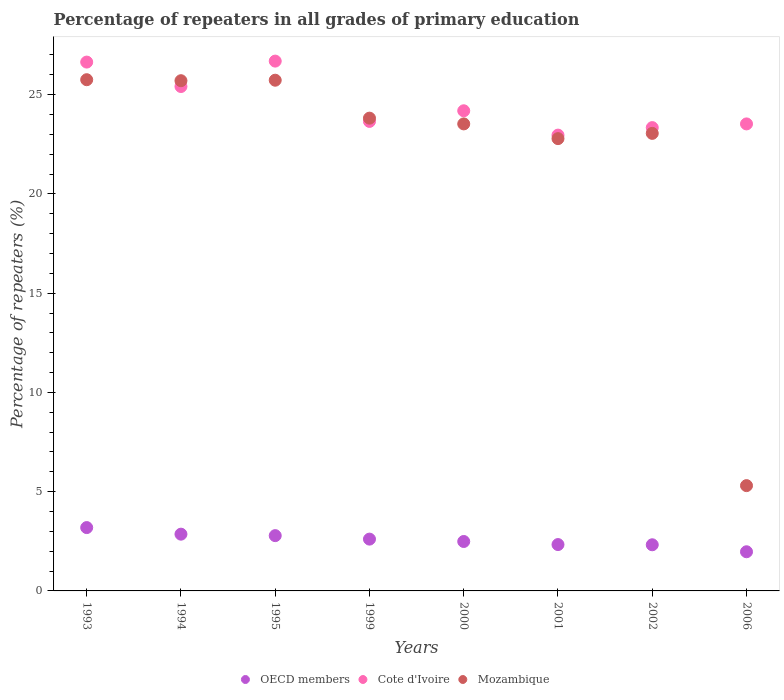How many different coloured dotlines are there?
Keep it short and to the point. 3. What is the percentage of repeaters in Cote d'Ivoire in 1995?
Your answer should be very brief. 26.69. Across all years, what is the maximum percentage of repeaters in OECD members?
Keep it short and to the point. 3.19. Across all years, what is the minimum percentage of repeaters in Mozambique?
Offer a very short reply. 5.3. In which year was the percentage of repeaters in OECD members minimum?
Your answer should be very brief. 2006. What is the total percentage of repeaters in Cote d'Ivoire in the graph?
Provide a short and direct response. 196.41. What is the difference between the percentage of repeaters in Cote d'Ivoire in 1995 and that in 2006?
Give a very brief answer. 3.16. What is the difference between the percentage of repeaters in Cote d'Ivoire in 2002 and the percentage of repeaters in Mozambique in 1995?
Provide a short and direct response. -2.39. What is the average percentage of repeaters in Mozambique per year?
Offer a very short reply. 21.96. In the year 1994, what is the difference between the percentage of repeaters in Mozambique and percentage of repeaters in OECD members?
Keep it short and to the point. 22.84. In how many years, is the percentage of repeaters in Cote d'Ivoire greater than 19 %?
Give a very brief answer. 8. What is the ratio of the percentage of repeaters in OECD members in 1995 to that in 2006?
Make the answer very short. 1.41. Is the difference between the percentage of repeaters in Mozambique in 1999 and 2000 greater than the difference between the percentage of repeaters in OECD members in 1999 and 2000?
Provide a short and direct response. Yes. What is the difference between the highest and the second highest percentage of repeaters in Cote d'Ivoire?
Offer a terse response. 0.05. What is the difference between the highest and the lowest percentage of repeaters in Mozambique?
Give a very brief answer. 20.45. Is the sum of the percentage of repeaters in Mozambique in 1993 and 2002 greater than the maximum percentage of repeaters in Cote d'Ivoire across all years?
Keep it short and to the point. Yes. Is it the case that in every year, the sum of the percentage of repeaters in Mozambique and percentage of repeaters in OECD members  is greater than the percentage of repeaters in Cote d'Ivoire?
Keep it short and to the point. No. Does the percentage of repeaters in Mozambique monotonically increase over the years?
Your response must be concise. No. How many dotlines are there?
Give a very brief answer. 3. How many years are there in the graph?
Your answer should be very brief. 8. Are the values on the major ticks of Y-axis written in scientific E-notation?
Give a very brief answer. No. How many legend labels are there?
Your answer should be compact. 3. How are the legend labels stacked?
Your answer should be compact. Horizontal. What is the title of the graph?
Offer a terse response. Percentage of repeaters in all grades of primary education. Does "Latin America(developing only)" appear as one of the legend labels in the graph?
Your answer should be very brief. No. What is the label or title of the X-axis?
Your answer should be compact. Years. What is the label or title of the Y-axis?
Your response must be concise. Percentage of repeaters (%). What is the Percentage of repeaters (%) in OECD members in 1993?
Provide a succinct answer. 3.19. What is the Percentage of repeaters (%) of Cote d'Ivoire in 1993?
Your answer should be very brief. 26.64. What is the Percentage of repeaters (%) in Mozambique in 1993?
Ensure brevity in your answer.  25.75. What is the Percentage of repeaters (%) in OECD members in 1994?
Keep it short and to the point. 2.86. What is the Percentage of repeaters (%) of Cote d'Ivoire in 1994?
Offer a very short reply. 25.41. What is the Percentage of repeaters (%) of Mozambique in 1994?
Ensure brevity in your answer.  25.7. What is the Percentage of repeaters (%) of OECD members in 1995?
Your answer should be compact. 2.79. What is the Percentage of repeaters (%) in Cote d'Ivoire in 1995?
Give a very brief answer. 26.69. What is the Percentage of repeaters (%) of Mozambique in 1995?
Your answer should be very brief. 25.73. What is the Percentage of repeaters (%) in OECD members in 1999?
Provide a short and direct response. 2.61. What is the Percentage of repeaters (%) of Cote d'Ivoire in 1999?
Your response must be concise. 23.65. What is the Percentage of repeaters (%) in Mozambique in 1999?
Give a very brief answer. 23.82. What is the Percentage of repeaters (%) of OECD members in 2000?
Provide a succinct answer. 2.49. What is the Percentage of repeaters (%) of Cote d'Ivoire in 2000?
Keep it short and to the point. 24.19. What is the Percentage of repeaters (%) of Mozambique in 2000?
Make the answer very short. 23.53. What is the Percentage of repeaters (%) of OECD members in 2001?
Offer a very short reply. 2.34. What is the Percentage of repeaters (%) of Cote d'Ivoire in 2001?
Offer a terse response. 22.96. What is the Percentage of repeaters (%) in Mozambique in 2001?
Your answer should be very brief. 22.78. What is the Percentage of repeaters (%) in OECD members in 2002?
Provide a short and direct response. 2.32. What is the Percentage of repeaters (%) in Cote d'Ivoire in 2002?
Offer a terse response. 23.34. What is the Percentage of repeaters (%) in Mozambique in 2002?
Your answer should be compact. 23.05. What is the Percentage of repeaters (%) of OECD members in 2006?
Ensure brevity in your answer.  1.97. What is the Percentage of repeaters (%) in Cote d'Ivoire in 2006?
Your response must be concise. 23.53. What is the Percentage of repeaters (%) in Mozambique in 2006?
Your response must be concise. 5.3. Across all years, what is the maximum Percentage of repeaters (%) in OECD members?
Your answer should be very brief. 3.19. Across all years, what is the maximum Percentage of repeaters (%) in Cote d'Ivoire?
Your answer should be compact. 26.69. Across all years, what is the maximum Percentage of repeaters (%) of Mozambique?
Your answer should be compact. 25.75. Across all years, what is the minimum Percentage of repeaters (%) in OECD members?
Keep it short and to the point. 1.97. Across all years, what is the minimum Percentage of repeaters (%) of Cote d'Ivoire?
Make the answer very short. 22.96. Across all years, what is the minimum Percentage of repeaters (%) in Mozambique?
Your answer should be very brief. 5.3. What is the total Percentage of repeaters (%) of OECD members in the graph?
Your response must be concise. 20.57. What is the total Percentage of repeaters (%) in Cote d'Ivoire in the graph?
Give a very brief answer. 196.41. What is the total Percentage of repeaters (%) in Mozambique in the graph?
Keep it short and to the point. 175.67. What is the difference between the Percentage of repeaters (%) of OECD members in 1993 and that in 1994?
Ensure brevity in your answer.  0.33. What is the difference between the Percentage of repeaters (%) in Cote d'Ivoire in 1993 and that in 1994?
Offer a very short reply. 1.23. What is the difference between the Percentage of repeaters (%) in Mozambique in 1993 and that in 1994?
Make the answer very short. 0.05. What is the difference between the Percentage of repeaters (%) of OECD members in 1993 and that in 1995?
Offer a terse response. 0.41. What is the difference between the Percentage of repeaters (%) of Cote d'Ivoire in 1993 and that in 1995?
Your answer should be compact. -0.05. What is the difference between the Percentage of repeaters (%) in Mozambique in 1993 and that in 1995?
Give a very brief answer. 0.03. What is the difference between the Percentage of repeaters (%) in OECD members in 1993 and that in 1999?
Your response must be concise. 0.58. What is the difference between the Percentage of repeaters (%) of Cote d'Ivoire in 1993 and that in 1999?
Provide a short and direct response. 2.99. What is the difference between the Percentage of repeaters (%) in Mozambique in 1993 and that in 1999?
Your answer should be compact. 1.94. What is the difference between the Percentage of repeaters (%) in OECD members in 1993 and that in 2000?
Your answer should be compact. 0.7. What is the difference between the Percentage of repeaters (%) in Cote d'Ivoire in 1993 and that in 2000?
Keep it short and to the point. 2.45. What is the difference between the Percentage of repeaters (%) of Mozambique in 1993 and that in 2000?
Provide a succinct answer. 2.23. What is the difference between the Percentage of repeaters (%) of OECD members in 1993 and that in 2001?
Provide a short and direct response. 0.86. What is the difference between the Percentage of repeaters (%) of Cote d'Ivoire in 1993 and that in 2001?
Your response must be concise. 3.68. What is the difference between the Percentage of repeaters (%) in Mozambique in 1993 and that in 2001?
Provide a succinct answer. 2.97. What is the difference between the Percentage of repeaters (%) in OECD members in 1993 and that in 2002?
Your answer should be compact. 0.87. What is the difference between the Percentage of repeaters (%) of Cote d'Ivoire in 1993 and that in 2002?
Give a very brief answer. 3.3. What is the difference between the Percentage of repeaters (%) of Mozambique in 1993 and that in 2002?
Make the answer very short. 2.7. What is the difference between the Percentage of repeaters (%) of OECD members in 1993 and that in 2006?
Your answer should be compact. 1.22. What is the difference between the Percentage of repeaters (%) in Cote d'Ivoire in 1993 and that in 2006?
Offer a very short reply. 3.11. What is the difference between the Percentage of repeaters (%) of Mozambique in 1993 and that in 2006?
Offer a very short reply. 20.45. What is the difference between the Percentage of repeaters (%) in OECD members in 1994 and that in 1995?
Provide a short and direct response. 0.07. What is the difference between the Percentage of repeaters (%) in Cote d'Ivoire in 1994 and that in 1995?
Your response must be concise. -1.28. What is the difference between the Percentage of repeaters (%) in Mozambique in 1994 and that in 1995?
Give a very brief answer. -0.02. What is the difference between the Percentage of repeaters (%) of OECD members in 1994 and that in 1999?
Your answer should be compact. 0.25. What is the difference between the Percentage of repeaters (%) of Cote d'Ivoire in 1994 and that in 1999?
Keep it short and to the point. 1.76. What is the difference between the Percentage of repeaters (%) in Mozambique in 1994 and that in 1999?
Offer a terse response. 1.89. What is the difference between the Percentage of repeaters (%) of OECD members in 1994 and that in 2000?
Give a very brief answer. 0.37. What is the difference between the Percentage of repeaters (%) of Cote d'Ivoire in 1994 and that in 2000?
Offer a very short reply. 1.22. What is the difference between the Percentage of repeaters (%) of Mozambique in 1994 and that in 2000?
Offer a very short reply. 2.18. What is the difference between the Percentage of repeaters (%) in OECD members in 1994 and that in 2001?
Offer a very short reply. 0.52. What is the difference between the Percentage of repeaters (%) in Cote d'Ivoire in 1994 and that in 2001?
Your response must be concise. 2.45. What is the difference between the Percentage of repeaters (%) of Mozambique in 1994 and that in 2001?
Your answer should be very brief. 2.92. What is the difference between the Percentage of repeaters (%) of OECD members in 1994 and that in 2002?
Offer a terse response. 0.53. What is the difference between the Percentage of repeaters (%) in Cote d'Ivoire in 1994 and that in 2002?
Keep it short and to the point. 2.07. What is the difference between the Percentage of repeaters (%) in Mozambique in 1994 and that in 2002?
Keep it short and to the point. 2.65. What is the difference between the Percentage of repeaters (%) of OECD members in 1994 and that in 2006?
Your answer should be very brief. 0.89. What is the difference between the Percentage of repeaters (%) in Cote d'Ivoire in 1994 and that in 2006?
Make the answer very short. 1.88. What is the difference between the Percentage of repeaters (%) of Mozambique in 1994 and that in 2006?
Ensure brevity in your answer.  20.4. What is the difference between the Percentage of repeaters (%) of OECD members in 1995 and that in 1999?
Your answer should be compact. 0.18. What is the difference between the Percentage of repeaters (%) of Cote d'Ivoire in 1995 and that in 1999?
Your response must be concise. 3.04. What is the difference between the Percentage of repeaters (%) in Mozambique in 1995 and that in 1999?
Offer a terse response. 1.91. What is the difference between the Percentage of repeaters (%) in OECD members in 1995 and that in 2000?
Offer a terse response. 0.29. What is the difference between the Percentage of repeaters (%) in Cote d'Ivoire in 1995 and that in 2000?
Provide a short and direct response. 2.5. What is the difference between the Percentage of repeaters (%) in Mozambique in 1995 and that in 2000?
Your answer should be very brief. 2.2. What is the difference between the Percentage of repeaters (%) of OECD members in 1995 and that in 2001?
Make the answer very short. 0.45. What is the difference between the Percentage of repeaters (%) of Cote d'Ivoire in 1995 and that in 2001?
Give a very brief answer. 3.73. What is the difference between the Percentage of repeaters (%) in Mozambique in 1995 and that in 2001?
Offer a very short reply. 2.94. What is the difference between the Percentage of repeaters (%) in OECD members in 1995 and that in 2002?
Keep it short and to the point. 0.46. What is the difference between the Percentage of repeaters (%) of Cote d'Ivoire in 1995 and that in 2002?
Give a very brief answer. 3.35. What is the difference between the Percentage of repeaters (%) in Mozambique in 1995 and that in 2002?
Ensure brevity in your answer.  2.68. What is the difference between the Percentage of repeaters (%) of OECD members in 1995 and that in 2006?
Offer a very short reply. 0.81. What is the difference between the Percentage of repeaters (%) of Cote d'Ivoire in 1995 and that in 2006?
Your answer should be compact. 3.16. What is the difference between the Percentage of repeaters (%) in Mozambique in 1995 and that in 2006?
Provide a short and direct response. 20.42. What is the difference between the Percentage of repeaters (%) in OECD members in 1999 and that in 2000?
Provide a short and direct response. 0.12. What is the difference between the Percentage of repeaters (%) in Cote d'Ivoire in 1999 and that in 2000?
Offer a very short reply. -0.54. What is the difference between the Percentage of repeaters (%) of Mozambique in 1999 and that in 2000?
Your response must be concise. 0.29. What is the difference between the Percentage of repeaters (%) in OECD members in 1999 and that in 2001?
Your answer should be compact. 0.27. What is the difference between the Percentage of repeaters (%) of Cote d'Ivoire in 1999 and that in 2001?
Your answer should be compact. 0.69. What is the difference between the Percentage of repeaters (%) in Mozambique in 1999 and that in 2001?
Provide a short and direct response. 1.03. What is the difference between the Percentage of repeaters (%) in OECD members in 1999 and that in 2002?
Offer a terse response. 0.29. What is the difference between the Percentage of repeaters (%) of Cote d'Ivoire in 1999 and that in 2002?
Ensure brevity in your answer.  0.31. What is the difference between the Percentage of repeaters (%) of Mozambique in 1999 and that in 2002?
Your answer should be compact. 0.77. What is the difference between the Percentage of repeaters (%) in OECD members in 1999 and that in 2006?
Keep it short and to the point. 0.64. What is the difference between the Percentage of repeaters (%) in Cote d'Ivoire in 1999 and that in 2006?
Your response must be concise. 0.13. What is the difference between the Percentage of repeaters (%) in Mozambique in 1999 and that in 2006?
Your response must be concise. 18.51. What is the difference between the Percentage of repeaters (%) in OECD members in 2000 and that in 2001?
Provide a succinct answer. 0.15. What is the difference between the Percentage of repeaters (%) of Cote d'Ivoire in 2000 and that in 2001?
Your response must be concise. 1.23. What is the difference between the Percentage of repeaters (%) in Mozambique in 2000 and that in 2001?
Your response must be concise. 0.74. What is the difference between the Percentage of repeaters (%) of OECD members in 2000 and that in 2002?
Your response must be concise. 0.17. What is the difference between the Percentage of repeaters (%) in Cote d'Ivoire in 2000 and that in 2002?
Provide a short and direct response. 0.85. What is the difference between the Percentage of repeaters (%) of Mozambique in 2000 and that in 2002?
Provide a short and direct response. 0.48. What is the difference between the Percentage of repeaters (%) in OECD members in 2000 and that in 2006?
Offer a very short reply. 0.52. What is the difference between the Percentage of repeaters (%) of Cote d'Ivoire in 2000 and that in 2006?
Offer a terse response. 0.66. What is the difference between the Percentage of repeaters (%) in Mozambique in 2000 and that in 2006?
Make the answer very short. 18.22. What is the difference between the Percentage of repeaters (%) of OECD members in 2001 and that in 2002?
Your response must be concise. 0.01. What is the difference between the Percentage of repeaters (%) in Cote d'Ivoire in 2001 and that in 2002?
Keep it short and to the point. -0.38. What is the difference between the Percentage of repeaters (%) in Mozambique in 2001 and that in 2002?
Your answer should be very brief. -0.26. What is the difference between the Percentage of repeaters (%) in OECD members in 2001 and that in 2006?
Keep it short and to the point. 0.36. What is the difference between the Percentage of repeaters (%) of Cote d'Ivoire in 2001 and that in 2006?
Your answer should be compact. -0.56. What is the difference between the Percentage of repeaters (%) of Mozambique in 2001 and that in 2006?
Offer a terse response. 17.48. What is the difference between the Percentage of repeaters (%) of OECD members in 2002 and that in 2006?
Ensure brevity in your answer.  0.35. What is the difference between the Percentage of repeaters (%) in Cote d'Ivoire in 2002 and that in 2006?
Offer a very short reply. -0.19. What is the difference between the Percentage of repeaters (%) in Mozambique in 2002 and that in 2006?
Ensure brevity in your answer.  17.75. What is the difference between the Percentage of repeaters (%) in OECD members in 1993 and the Percentage of repeaters (%) in Cote d'Ivoire in 1994?
Make the answer very short. -22.22. What is the difference between the Percentage of repeaters (%) in OECD members in 1993 and the Percentage of repeaters (%) in Mozambique in 1994?
Offer a very short reply. -22.51. What is the difference between the Percentage of repeaters (%) of Cote d'Ivoire in 1993 and the Percentage of repeaters (%) of Mozambique in 1994?
Your answer should be very brief. 0.94. What is the difference between the Percentage of repeaters (%) in OECD members in 1993 and the Percentage of repeaters (%) in Cote d'Ivoire in 1995?
Your answer should be very brief. -23.5. What is the difference between the Percentage of repeaters (%) in OECD members in 1993 and the Percentage of repeaters (%) in Mozambique in 1995?
Your answer should be very brief. -22.54. What is the difference between the Percentage of repeaters (%) of Cote d'Ivoire in 1993 and the Percentage of repeaters (%) of Mozambique in 1995?
Offer a very short reply. 0.91. What is the difference between the Percentage of repeaters (%) in OECD members in 1993 and the Percentage of repeaters (%) in Cote d'Ivoire in 1999?
Give a very brief answer. -20.46. What is the difference between the Percentage of repeaters (%) of OECD members in 1993 and the Percentage of repeaters (%) of Mozambique in 1999?
Offer a terse response. -20.63. What is the difference between the Percentage of repeaters (%) of Cote d'Ivoire in 1993 and the Percentage of repeaters (%) of Mozambique in 1999?
Ensure brevity in your answer.  2.82. What is the difference between the Percentage of repeaters (%) in OECD members in 1993 and the Percentage of repeaters (%) in Cote d'Ivoire in 2000?
Keep it short and to the point. -21. What is the difference between the Percentage of repeaters (%) in OECD members in 1993 and the Percentage of repeaters (%) in Mozambique in 2000?
Make the answer very short. -20.34. What is the difference between the Percentage of repeaters (%) of Cote d'Ivoire in 1993 and the Percentage of repeaters (%) of Mozambique in 2000?
Provide a short and direct response. 3.11. What is the difference between the Percentage of repeaters (%) in OECD members in 1993 and the Percentage of repeaters (%) in Cote d'Ivoire in 2001?
Provide a short and direct response. -19.77. What is the difference between the Percentage of repeaters (%) of OECD members in 1993 and the Percentage of repeaters (%) of Mozambique in 2001?
Keep it short and to the point. -19.59. What is the difference between the Percentage of repeaters (%) of Cote d'Ivoire in 1993 and the Percentage of repeaters (%) of Mozambique in 2001?
Keep it short and to the point. 3.86. What is the difference between the Percentage of repeaters (%) of OECD members in 1993 and the Percentage of repeaters (%) of Cote d'Ivoire in 2002?
Your answer should be compact. -20.15. What is the difference between the Percentage of repeaters (%) of OECD members in 1993 and the Percentage of repeaters (%) of Mozambique in 2002?
Provide a short and direct response. -19.86. What is the difference between the Percentage of repeaters (%) of Cote d'Ivoire in 1993 and the Percentage of repeaters (%) of Mozambique in 2002?
Your response must be concise. 3.59. What is the difference between the Percentage of repeaters (%) of OECD members in 1993 and the Percentage of repeaters (%) of Cote d'Ivoire in 2006?
Make the answer very short. -20.34. What is the difference between the Percentage of repeaters (%) of OECD members in 1993 and the Percentage of repeaters (%) of Mozambique in 2006?
Give a very brief answer. -2.11. What is the difference between the Percentage of repeaters (%) of Cote d'Ivoire in 1993 and the Percentage of repeaters (%) of Mozambique in 2006?
Ensure brevity in your answer.  21.34. What is the difference between the Percentage of repeaters (%) in OECD members in 1994 and the Percentage of repeaters (%) in Cote d'Ivoire in 1995?
Provide a short and direct response. -23.83. What is the difference between the Percentage of repeaters (%) in OECD members in 1994 and the Percentage of repeaters (%) in Mozambique in 1995?
Offer a terse response. -22.87. What is the difference between the Percentage of repeaters (%) in Cote d'Ivoire in 1994 and the Percentage of repeaters (%) in Mozambique in 1995?
Make the answer very short. -0.32. What is the difference between the Percentage of repeaters (%) in OECD members in 1994 and the Percentage of repeaters (%) in Cote d'Ivoire in 1999?
Your answer should be compact. -20.79. What is the difference between the Percentage of repeaters (%) in OECD members in 1994 and the Percentage of repeaters (%) in Mozambique in 1999?
Your response must be concise. -20.96. What is the difference between the Percentage of repeaters (%) of Cote d'Ivoire in 1994 and the Percentage of repeaters (%) of Mozambique in 1999?
Your answer should be compact. 1.59. What is the difference between the Percentage of repeaters (%) in OECD members in 1994 and the Percentage of repeaters (%) in Cote d'Ivoire in 2000?
Give a very brief answer. -21.33. What is the difference between the Percentage of repeaters (%) of OECD members in 1994 and the Percentage of repeaters (%) of Mozambique in 2000?
Provide a short and direct response. -20.67. What is the difference between the Percentage of repeaters (%) in Cote d'Ivoire in 1994 and the Percentage of repeaters (%) in Mozambique in 2000?
Give a very brief answer. 1.88. What is the difference between the Percentage of repeaters (%) in OECD members in 1994 and the Percentage of repeaters (%) in Cote d'Ivoire in 2001?
Provide a succinct answer. -20.1. What is the difference between the Percentage of repeaters (%) of OECD members in 1994 and the Percentage of repeaters (%) of Mozambique in 2001?
Provide a short and direct response. -19.93. What is the difference between the Percentage of repeaters (%) of Cote d'Ivoire in 1994 and the Percentage of repeaters (%) of Mozambique in 2001?
Ensure brevity in your answer.  2.63. What is the difference between the Percentage of repeaters (%) in OECD members in 1994 and the Percentage of repeaters (%) in Cote d'Ivoire in 2002?
Ensure brevity in your answer.  -20.48. What is the difference between the Percentage of repeaters (%) of OECD members in 1994 and the Percentage of repeaters (%) of Mozambique in 2002?
Provide a succinct answer. -20.19. What is the difference between the Percentage of repeaters (%) in Cote d'Ivoire in 1994 and the Percentage of repeaters (%) in Mozambique in 2002?
Keep it short and to the point. 2.36. What is the difference between the Percentage of repeaters (%) in OECD members in 1994 and the Percentage of repeaters (%) in Cote d'Ivoire in 2006?
Give a very brief answer. -20.67. What is the difference between the Percentage of repeaters (%) in OECD members in 1994 and the Percentage of repeaters (%) in Mozambique in 2006?
Your answer should be compact. -2.45. What is the difference between the Percentage of repeaters (%) in Cote d'Ivoire in 1994 and the Percentage of repeaters (%) in Mozambique in 2006?
Offer a very short reply. 20.11. What is the difference between the Percentage of repeaters (%) of OECD members in 1995 and the Percentage of repeaters (%) of Cote d'Ivoire in 1999?
Give a very brief answer. -20.87. What is the difference between the Percentage of repeaters (%) of OECD members in 1995 and the Percentage of repeaters (%) of Mozambique in 1999?
Make the answer very short. -21.03. What is the difference between the Percentage of repeaters (%) in Cote d'Ivoire in 1995 and the Percentage of repeaters (%) in Mozambique in 1999?
Your answer should be very brief. 2.87. What is the difference between the Percentage of repeaters (%) in OECD members in 1995 and the Percentage of repeaters (%) in Cote d'Ivoire in 2000?
Offer a very short reply. -21.4. What is the difference between the Percentage of repeaters (%) of OECD members in 1995 and the Percentage of repeaters (%) of Mozambique in 2000?
Keep it short and to the point. -20.74. What is the difference between the Percentage of repeaters (%) in Cote d'Ivoire in 1995 and the Percentage of repeaters (%) in Mozambique in 2000?
Offer a terse response. 3.16. What is the difference between the Percentage of repeaters (%) in OECD members in 1995 and the Percentage of repeaters (%) in Cote d'Ivoire in 2001?
Keep it short and to the point. -20.18. What is the difference between the Percentage of repeaters (%) of OECD members in 1995 and the Percentage of repeaters (%) of Mozambique in 2001?
Your answer should be very brief. -20. What is the difference between the Percentage of repeaters (%) of Cote d'Ivoire in 1995 and the Percentage of repeaters (%) of Mozambique in 2001?
Your answer should be compact. 3.91. What is the difference between the Percentage of repeaters (%) in OECD members in 1995 and the Percentage of repeaters (%) in Cote d'Ivoire in 2002?
Provide a succinct answer. -20.55. What is the difference between the Percentage of repeaters (%) in OECD members in 1995 and the Percentage of repeaters (%) in Mozambique in 2002?
Offer a terse response. -20.26. What is the difference between the Percentage of repeaters (%) in Cote d'Ivoire in 1995 and the Percentage of repeaters (%) in Mozambique in 2002?
Offer a terse response. 3.64. What is the difference between the Percentage of repeaters (%) in OECD members in 1995 and the Percentage of repeaters (%) in Cote d'Ivoire in 2006?
Ensure brevity in your answer.  -20.74. What is the difference between the Percentage of repeaters (%) in OECD members in 1995 and the Percentage of repeaters (%) in Mozambique in 2006?
Offer a very short reply. -2.52. What is the difference between the Percentage of repeaters (%) in Cote d'Ivoire in 1995 and the Percentage of repeaters (%) in Mozambique in 2006?
Make the answer very short. 21.39. What is the difference between the Percentage of repeaters (%) in OECD members in 1999 and the Percentage of repeaters (%) in Cote d'Ivoire in 2000?
Give a very brief answer. -21.58. What is the difference between the Percentage of repeaters (%) in OECD members in 1999 and the Percentage of repeaters (%) in Mozambique in 2000?
Make the answer very short. -20.92. What is the difference between the Percentage of repeaters (%) in Cote d'Ivoire in 1999 and the Percentage of repeaters (%) in Mozambique in 2000?
Offer a very short reply. 0.13. What is the difference between the Percentage of repeaters (%) in OECD members in 1999 and the Percentage of repeaters (%) in Cote d'Ivoire in 2001?
Offer a terse response. -20.35. What is the difference between the Percentage of repeaters (%) in OECD members in 1999 and the Percentage of repeaters (%) in Mozambique in 2001?
Your answer should be very brief. -20.18. What is the difference between the Percentage of repeaters (%) in Cote d'Ivoire in 1999 and the Percentage of repeaters (%) in Mozambique in 2001?
Your response must be concise. 0.87. What is the difference between the Percentage of repeaters (%) of OECD members in 1999 and the Percentage of repeaters (%) of Cote d'Ivoire in 2002?
Your response must be concise. -20.73. What is the difference between the Percentage of repeaters (%) of OECD members in 1999 and the Percentage of repeaters (%) of Mozambique in 2002?
Provide a short and direct response. -20.44. What is the difference between the Percentage of repeaters (%) in Cote d'Ivoire in 1999 and the Percentage of repeaters (%) in Mozambique in 2002?
Provide a short and direct response. 0.6. What is the difference between the Percentage of repeaters (%) of OECD members in 1999 and the Percentage of repeaters (%) of Cote d'Ivoire in 2006?
Keep it short and to the point. -20.92. What is the difference between the Percentage of repeaters (%) of OECD members in 1999 and the Percentage of repeaters (%) of Mozambique in 2006?
Your answer should be very brief. -2.69. What is the difference between the Percentage of repeaters (%) of Cote d'Ivoire in 1999 and the Percentage of repeaters (%) of Mozambique in 2006?
Keep it short and to the point. 18.35. What is the difference between the Percentage of repeaters (%) in OECD members in 2000 and the Percentage of repeaters (%) in Cote d'Ivoire in 2001?
Offer a terse response. -20.47. What is the difference between the Percentage of repeaters (%) in OECD members in 2000 and the Percentage of repeaters (%) in Mozambique in 2001?
Provide a succinct answer. -20.29. What is the difference between the Percentage of repeaters (%) in Cote d'Ivoire in 2000 and the Percentage of repeaters (%) in Mozambique in 2001?
Ensure brevity in your answer.  1.4. What is the difference between the Percentage of repeaters (%) in OECD members in 2000 and the Percentage of repeaters (%) in Cote d'Ivoire in 2002?
Offer a terse response. -20.85. What is the difference between the Percentage of repeaters (%) of OECD members in 2000 and the Percentage of repeaters (%) of Mozambique in 2002?
Make the answer very short. -20.56. What is the difference between the Percentage of repeaters (%) of Cote d'Ivoire in 2000 and the Percentage of repeaters (%) of Mozambique in 2002?
Keep it short and to the point. 1.14. What is the difference between the Percentage of repeaters (%) of OECD members in 2000 and the Percentage of repeaters (%) of Cote d'Ivoire in 2006?
Your answer should be very brief. -21.04. What is the difference between the Percentage of repeaters (%) in OECD members in 2000 and the Percentage of repeaters (%) in Mozambique in 2006?
Give a very brief answer. -2.81. What is the difference between the Percentage of repeaters (%) of Cote d'Ivoire in 2000 and the Percentage of repeaters (%) of Mozambique in 2006?
Provide a succinct answer. 18.88. What is the difference between the Percentage of repeaters (%) of OECD members in 2001 and the Percentage of repeaters (%) of Cote d'Ivoire in 2002?
Offer a terse response. -21. What is the difference between the Percentage of repeaters (%) of OECD members in 2001 and the Percentage of repeaters (%) of Mozambique in 2002?
Your answer should be compact. -20.71. What is the difference between the Percentage of repeaters (%) in Cote d'Ivoire in 2001 and the Percentage of repeaters (%) in Mozambique in 2002?
Keep it short and to the point. -0.09. What is the difference between the Percentage of repeaters (%) of OECD members in 2001 and the Percentage of repeaters (%) of Cote d'Ivoire in 2006?
Make the answer very short. -21.19. What is the difference between the Percentage of repeaters (%) in OECD members in 2001 and the Percentage of repeaters (%) in Mozambique in 2006?
Provide a succinct answer. -2.97. What is the difference between the Percentage of repeaters (%) in Cote d'Ivoire in 2001 and the Percentage of repeaters (%) in Mozambique in 2006?
Provide a short and direct response. 17.66. What is the difference between the Percentage of repeaters (%) of OECD members in 2002 and the Percentage of repeaters (%) of Cote d'Ivoire in 2006?
Provide a short and direct response. -21.2. What is the difference between the Percentage of repeaters (%) in OECD members in 2002 and the Percentage of repeaters (%) in Mozambique in 2006?
Your answer should be very brief. -2.98. What is the difference between the Percentage of repeaters (%) of Cote d'Ivoire in 2002 and the Percentage of repeaters (%) of Mozambique in 2006?
Give a very brief answer. 18.04. What is the average Percentage of repeaters (%) in OECD members per year?
Your response must be concise. 2.57. What is the average Percentage of repeaters (%) of Cote d'Ivoire per year?
Your response must be concise. 24.55. What is the average Percentage of repeaters (%) in Mozambique per year?
Keep it short and to the point. 21.96. In the year 1993, what is the difference between the Percentage of repeaters (%) in OECD members and Percentage of repeaters (%) in Cote d'Ivoire?
Make the answer very short. -23.45. In the year 1993, what is the difference between the Percentage of repeaters (%) in OECD members and Percentage of repeaters (%) in Mozambique?
Provide a short and direct response. -22.56. In the year 1993, what is the difference between the Percentage of repeaters (%) of Cote d'Ivoire and Percentage of repeaters (%) of Mozambique?
Give a very brief answer. 0.89. In the year 1994, what is the difference between the Percentage of repeaters (%) of OECD members and Percentage of repeaters (%) of Cote d'Ivoire?
Offer a terse response. -22.55. In the year 1994, what is the difference between the Percentage of repeaters (%) of OECD members and Percentage of repeaters (%) of Mozambique?
Provide a succinct answer. -22.84. In the year 1994, what is the difference between the Percentage of repeaters (%) in Cote d'Ivoire and Percentage of repeaters (%) in Mozambique?
Make the answer very short. -0.29. In the year 1995, what is the difference between the Percentage of repeaters (%) of OECD members and Percentage of repeaters (%) of Cote d'Ivoire?
Your answer should be very brief. -23.91. In the year 1995, what is the difference between the Percentage of repeaters (%) in OECD members and Percentage of repeaters (%) in Mozambique?
Your answer should be compact. -22.94. In the year 1995, what is the difference between the Percentage of repeaters (%) in Cote d'Ivoire and Percentage of repeaters (%) in Mozambique?
Make the answer very short. 0.96. In the year 1999, what is the difference between the Percentage of repeaters (%) in OECD members and Percentage of repeaters (%) in Cote d'Ivoire?
Your response must be concise. -21.04. In the year 1999, what is the difference between the Percentage of repeaters (%) in OECD members and Percentage of repeaters (%) in Mozambique?
Ensure brevity in your answer.  -21.21. In the year 1999, what is the difference between the Percentage of repeaters (%) of Cote d'Ivoire and Percentage of repeaters (%) of Mozambique?
Your answer should be very brief. -0.16. In the year 2000, what is the difference between the Percentage of repeaters (%) in OECD members and Percentage of repeaters (%) in Cote d'Ivoire?
Keep it short and to the point. -21.7. In the year 2000, what is the difference between the Percentage of repeaters (%) in OECD members and Percentage of repeaters (%) in Mozambique?
Provide a succinct answer. -21.04. In the year 2000, what is the difference between the Percentage of repeaters (%) of Cote d'Ivoire and Percentage of repeaters (%) of Mozambique?
Give a very brief answer. 0.66. In the year 2001, what is the difference between the Percentage of repeaters (%) in OECD members and Percentage of repeaters (%) in Cote d'Ivoire?
Provide a short and direct response. -20.63. In the year 2001, what is the difference between the Percentage of repeaters (%) in OECD members and Percentage of repeaters (%) in Mozambique?
Keep it short and to the point. -20.45. In the year 2001, what is the difference between the Percentage of repeaters (%) in Cote d'Ivoire and Percentage of repeaters (%) in Mozambique?
Give a very brief answer. 0.18. In the year 2002, what is the difference between the Percentage of repeaters (%) of OECD members and Percentage of repeaters (%) of Cote d'Ivoire?
Ensure brevity in your answer.  -21.02. In the year 2002, what is the difference between the Percentage of repeaters (%) of OECD members and Percentage of repeaters (%) of Mozambique?
Offer a terse response. -20.73. In the year 2002, what is the difference between the Percentage of repeaters (%) of Cote d'Ivoire and Percentage of repeaters (%) of Mozambique?
Make the answer very short. 0.29. In the year 2006, what is the difference between the Percentage of repeaters (%) of OECD members and Percentage of repeaters (%) of Cote d'Ivoire?
Your answer should be very brief. -21.55. In the year 2006, what is the difference between the Percentage of repeaters (%) of OECD members and Percentage of repeaters (%) of Mozambique?
Give a very brief answer. -3.33. In the year 2006, what is the difference between the Percentage of repeaters (%) of Cote d'Ivoire and Percentage of repeaters (%) of Mozambique?
Your answer should be compact. 18.22. What is the ratio of the Percentage of repeaters (%) in OECD members in 1993 to that in 1994?
Offer a terse response. 1.12. What is the ratio of the Percentage of repeaters (%) in Cote d'Ivoire in 1993 to that in 1994?
Offer a very short reply. 1.05. What is the ratio of the Percentage of repeaters (%) in Mozambique in 1993 to that in 1994?
Make the answer very short. 1. What is the ratio of the Percentage of repeaters (%) of OECD members in 1993 to that in 1995?
Keep it short and to the point. 1.15. What is the ratio of the Percentage of repeaters (%) in Mozambique in 1993 to that in 1995?
Make the answer very short. 1. What is the ratio of the Percentage of repeaters (%) of OECD members in 1993 to that in 1999?
Ensure brevity in your answer.  1.22. What is the ratio of the Percentage of repeaters (%) in Cote d'Ivoire in 1993 to that in 1999?
Provide a short and direct response. 1.13. What is the ratio of the Percentage of repeaters (%) in Mozambique in 1993 to that in 1999?
Ensure brevity in your answer.  1.08. What is the ratio of the Percentage of repeaters (%) of OECD members in 1993 to that in 2000?
Your response must be concise. 1.28. What is the ratio of the Percentage of repeaters (%) in Cote d'Ivoire in 1993 to that in 2000?
Ensure brevity in your answer.  1.1. What is the ratio of the Percentage of repeaters (%) in Mozambique in 1993 to that in 2000?
Provide a short and direct response. 1.09. What is the ratio of the Percentage of repeaters (%) of OECD members in 1993 to that in 2001?
Ensure brevity in your answer.  1.37. What is the ratio of the Percentage of repeaters (%) in Cote d'Ivoire in 1993 to that in 2001?
Your response must be concise. 1.16. What is the ratio of the Percentage of repeaters (%) in Mozambique in 1993 to that in 2001?
Ensure brevity in your answer.  1.13. What is the ratio of the Percentage of repeaters (%) of OECD members in 1993 to that in 2002?
Provide a succinct answer. 1.37. What is the ratio of the Percentage of repeaters (%) in Cote d'Ivoire in 1993 to that in 2002?
Your response must be concise. 1.14. What is the ratio of the Percentage of repeaters (%) of Mozambique in 1993 to that in 2002?
Offer a terse response. 1.12. What is the ratio of the Percentage of repeaters (%) of OECD members in 1993 to that in 2006?
Provide a succinct answer. 1.62. What is the ratio of the Percentage of repeaters (%) in Cote d'Ivoire in 1993 to that in 2006?
Provide a short and direct response. 1.13. What is the ratio of the Percentage of repeaters (%) in Mozambique in 1993 to that in 2006?
Make the answer very short. 4.86. What is the ratio of the Percentage of repeaters (%) of OECD members in 1994 to that in 1995?
Your answer should be compact. 1.03. What is the ratio of the Percentage of repeaters (%) of Cote d'Ivoire in 1994 to that in 1995?
Keep it short and to the point. 0.95. What is the ratio of the Percentage of repeaters (%) of OECD members in 1994 to that in 1999?
Your answer should be very brief. 1.1. What is the ratio of the Percentage of repeaters (%) in Cote d'Ivoire in 1994 to that in 1999?
Provide a succinct answer. 1.07. What is the ratio of the Percentage of repeaters (%) in Mozambique in 1994 to that in 1999?
Give a very brief answer. 1.08. What is the ratio of the Percentage of repeaters (%) in OECD members in 1994 to that in 2000?
Make the answer very short. 1.15. What is the ratio of the Percentage of repeaters (%) in Cote d'Ivoire in 1994 to that in 2000?
Offer a terse response. 1.05. What is the ratio of the Percentage of repeaters (%) in Mozambique in 1994 to that in 2000?
Your response must be concise. 1.09. What is the ratio of the Percentage of repeaters (%) in OECD members in 1994 to that in 2001?
Give a very brief answer. 1.22. What is the ratio of the Percentage of repeaters (%) of Cote d'Ivoire in 1994 to that in 2001?
Your answer should be compact. 1.11. What is the ratio of the Percentage of repeaters (%) of Mozambique in 1994 to that in 2001?
Provide a short and direct response. 1.13. What is the ratio of the Percentage of repeaters (%) in OECD members in 1994 to that in 2002?
Your answer should be very brief. 1.23. What is the ratio of the Percentage of repeaters (%) of Cote d'Ivoire in 1994 to that in 2002?
Provide a short and direct response. 1.09. What is the ratio of the Percentage of repeaters (%) in Mozambique in 1994 to that in 2002?
Offer a very short reply. 1.12. What is the ratio of the Percentage of repeaters (%) of OECD members in 1994 to that in 2006?
Give a very brief answer. 1.45. What is the ratio of the Percentage of repeaters (%) in Cote d'Ivoire in 1994 to that in 2006?
Give a very brief answer. 1.08. What is the ratio of the Percentage of repeaters (%) of Mozambique in 1994 to that in 2006?
Provide a succinct answer. 4.85. What is the ratio of the Percentage of repeaters (%) of OECD members in 1995 to that in 1999?
Offer a terse response. 1.07. What is the ratio of the Percentage of repeaters (%) in Cote d'Ivoire in 1995 to that in 1999?
Your response must be concise. 1.13. What is the ratio of the Percentage of repeaters (%) of Mozambique in 1995 to that in 1999?
Keep it short and to the point. 1.08. What is the ratio of the Percentage of repeaters (%) of OECD members in 1995 to that in 2000?
Your response must be concise. 1.12. What is the ratio of the Percentage of repeaters (%) in Cote d'Ivoire in 1995 to that in 2000?
Provide a succinct answer. 1.1. What is the ratio of the Percentage of repeaters (%) in Mozambique in 1995 to that in 2000?
Give a very brief answer. 1.09. What is the ratio of the Percentage of repeaters (%) of OECD members in 1995 to that in 2001?
Provide a succinct answer. 1.19. What is the ratio of the Percentage of repeaters (%) of Cote d'Ivoire in 1995 to that in 2001?
Offer a terse response. 1.16. What is the ratio of the Percentage of repeaters (%) in Mozambique in 1995 to that in 2001?
Your answer should be very brief. 1.13. What is the ratio of the Percentage of repeaters (%) of OECD members in 1995 to that in 2002?
Offer a terse response. 1.2. What is the ratio of the Percentage of repeaters (%) in Cote d'Ivoire in 1995 to that in 2002?
Your answer should be very brief. 1.14. What is the ratio of the Percentage of repeaters (%) in Mozambique in 1995 to that in 2002?
Provide a short and direct response. 1.12. What is the ratio of the Percentage of repeaters (%) in OECD members in 1995 to that in 2006?
Ensure brevity in your answer.  1.41. What is the ratio of the Percentage of repeaters (%) in Cote d'Ivoire in 1995 to that in 2006?
Your response must be concise. 1.13. What is the ratio of the Percentage of repeaters (%) of Mozambique in 1995 to that in 2006?
Your answer should be very brief. 4.85. What is the ratio of the Percentage of repeaters (%) of OECD members in 1999 to that in 2000?
Ensure brevity in your answer.  1.05. What is the ratio of the Percentage of repeaters (%) of Cote d'Ivoire in 1999 to that in 2000?
Offer a very short reply. 0.98. What is the ratio of the Percentage of repeaters (%) in Mozambique in 1999 to that in 2000?
Your response must be concise. 1.01. What is the ratio of the Percentage of repeaters (%) of OECD members in 1999 to that in 2001?
Your answer should be compact. 1.12. What is the ratio of the Percentage of repeaters (%) of Cote d'Ivoire in 1999 to that in 2001?
Provide a short and direct response. 1.03. What is the ratio of the Percentage of repeaters (%) of Mozambique in 1999 to that in 2001?
Your answer should be compact. 1.05. What is the ratio of the Percentage of repeaters (%) of OECD members in 1999 to that in 2002?
Keep it short and to the point. 1.12. What is the ratio of the Percentage of repeaters (%) of Cote d'Ivoire in 1999 to that in 2002?
Your answer should be compact. 1.01. What is the ratio of the Percentage of repeaters (%) in OECD members in 1999 to that in 2006?
Your answer should be very brief. 1.32. What is the ratio of the Percentage of repeaters (%) in Cote d'Ivoire in 1999 to that in 2006?
Keep it short and to the point. 1.01. What is the ratio of the Percentage of repeaters (%) in Mozambique in 1999 to that in 2006?
Give a very brief answer. 4.49. What is the ratio of the Percentage of repeaters (%) of OECD members in 2000 to that in 2001?
Your answer should be compact. 1.07. What is the ratio of the Percentage of repeaters (%) of Cote d'Ivoire in 2000 to that in 2001?
Your response must be concise. 1.05. What is the ratio of the Percentage of repeaters (%) in Mozambique in 2000 to that in 2001?
Ensure brevity in your answer.  1.03. What is the ratio of the Percentage of repeaters (%) of OECD members in 2000 to that in 2002?
Your response must be concise. 1.07. What is the ratio of the Percentage of repeaters (%) in Cote d'Ivoire in 2000 to that in 2002?
Offer a very short reply. 1.04. What is the ratio of the Percentage of repeaters (%) of Mozambique in 2000 to that in 2002?
Ensure brevity in your answer.  1.02. What is the ratio of the Percentage of repeaters (%) of OECD members in 2000 to that in 2006?
Provide a short and direct response. 1.26. What is the ratio of the Percentage of repeaters (%) of Cote d'Ivoire in 2000 to that in 2006?
Keep it short and to the point. 1.03. What is the ratio of the Percentage of repeaters (%) of Mozambique in 2000 to that in 2006?
Your answer should be compact. 4.44. What is the ratio of the Percentage of repeaters (%) of Cote d'Ivoire in 2001 to that in 2002?
Your response must be concise. 0.98. What is the ratio of the Percentage of repeaters (%) of OECD members in 2001 to that in 2006?
Ensure brevity in your answer.  1.18. What is the ratio of the Percentage of repeaters (%) of Mozambique in 2001 to that in 2006?
Your answer should be very brief. 4.3. What is the ratio of the Percentage of repeaters (%) in OECD members in 2002 to that in 2006?
Give a very brief answer. 1.18. What is the ratio of the Percentage of repeaters (%) in Mozambique in 2002 to that in 2006?
Offer a very short reply. 4.35. What is the difference between the highest and the second highest Percentage of repeaters (%) in OECD members?
Your response must be concise. 0.33. What is the difference between the highest and the second highest Percentage of repeaters (%) of Cote d'Ivoire?
Keep it short and to the point. 0.05. What is the difference between the highest and the second highest Percentage of repeaters (%) of Mozambique?
Give a very brief answer. 0.03. What is the difference between the highest and the lowest Percentage of repeaters (%) of OECD members?
Your answer should be compact. 1.22. What is the difference between the highest and the lowest Percentage of repeaters (%) in Cote d'Ivoire?
Your answer should be compact. 3.73. What is the difference between the highest and the lowest Percentage of repeaters (%) of Mozambique?
Your answer should be compact. 20.45. 